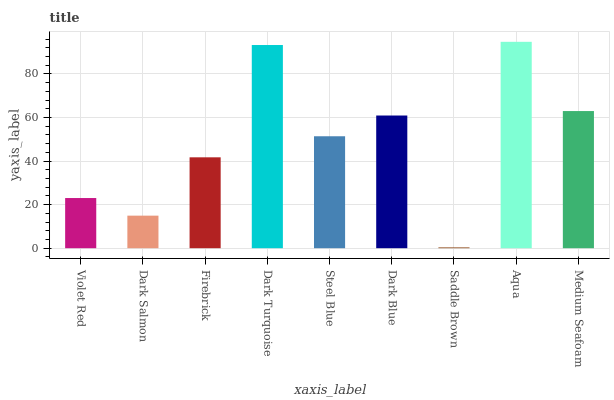Is Saddle Brown the minimum?
Answer yes or no. Yes. Is Aqua the maximum?
Answer yes or no. Yes. Is Dark Salmon the minimum?
Answer yes or no. No. Is Dark Salmon the maximum?
Answer yes or no. No. Is Violet Red greater than Dark Salmon?
Answer yes or no. Yes. Is Dark Salmon less than Violet Red?
Answer yes or no. Yes. Is Dark Salmon greater than Violet Red?
Answer yes or no. No. Is Violet Red less than Dark Salmon?
Answer yes or no. No. Is Steel Blue the high median?
Answer yes or no. Yes. Is Steel Blue the low median?
Answer yes or no. Yes. Is Dark Blue the high median?
Answer yes or no. No. Is Aqua the low median?
Answer yes or no. No. 